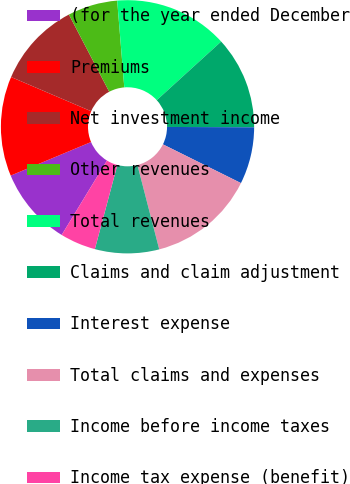Convert chart to OTSL. <chart><loc_0><loc_0><loc_500><loc_500><pie_chart><fcel>(for the year ended December<fcel>Premiums<fcel>Net investment income<fcel>Other revenues<fcel>Total revenues<fcel>Claims and claim adjustment<fcel>Interest expense<fcel>Total claims and expenses<fcel>Income before income taxes<fcel>Income tax expense (benefit)<nl><fcel>10.0%<fcel>12.73%<fcel>10.91%<fcel>6.36%<fcel>14.55%<fcel>11.82%<fcel>7.27%<fcel>13.64%<fcel>8.18%<fcel>4.55%<nl></chart> 